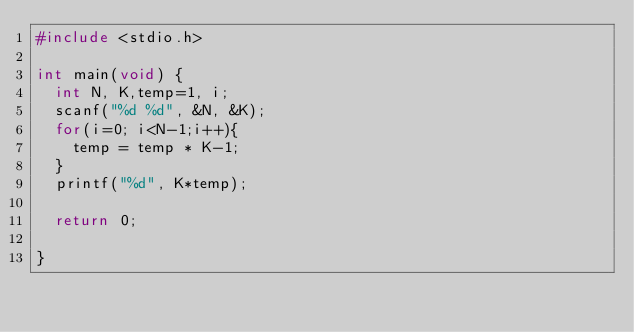Convert code to text. <code><loc_0><loc_0><loc_500><loc_500><_C_>#include <stdio.h>

int main(void) {
	int N, K,temp=1, i;
	scanf("%d %d", &N, &K);
	for(i=0; i<N-1;i++){
		temp = temp * K-1;
	}
	printf("%d", K*temp);
	
	return 0;

}
</code> 